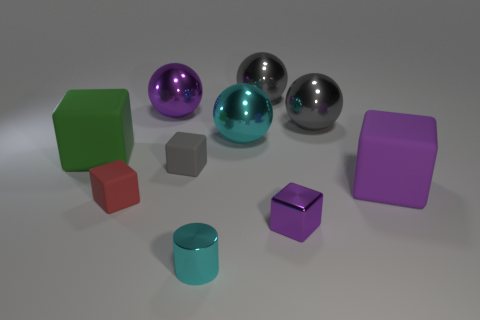Is the color of the small cube that is right of the small gray matte thing the same as the large thing that is in front of the green object?
Your response must be concise. Yes. There is a object that is the same color as the small cylinder; what shape is it?
Ensure brevity in your answer.  Sphere. What is the color of the tiny metallic thing right of the thing that is behind the big purple thing that is behind the tiny gray rubber cube?
Your response must be concise. Purple. What is the color of the small metallic thing that is the same shape as the red rubber thing?
Give a very brief answer. Purple. The green block is what size?
Offer a very short reply. Large. What is the color of the big cube on the left side of the small cyan cylinder?
Keep it short and to the point. Green. Is the size of the matte thing that is to the right of the tiny purple metallic cube the same as the purple shiny thing that is to the left of the small gray cube?
Offer a terse response. Yes. There is a large cube that is on the right side of the small red thing; how many big purple matte objects are in front of it?
Provide a short and direct response. 0. Do the small cylinder and the metallic cube have the same color?
Your answer should be very brief. No. Is the number of big purple metallic cylinders greater than the number of tiny gray blocks?
Provide a succinct answer. No. 